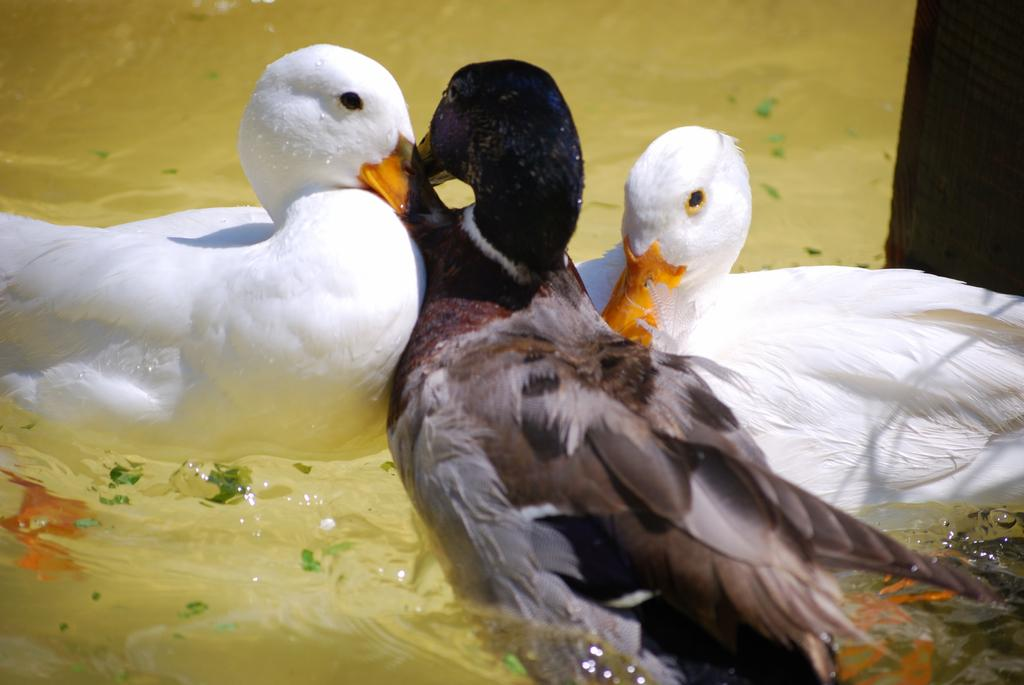How many birds are present in the image? There are three birds in the image. What colors are the birds? Two of the birds are white, and one is black. Where are the birds located in the image? The birds are on the water. What type of pie is being sold at the shop in the image? There is no shop or pie present in the image; it features three birds on the water. 